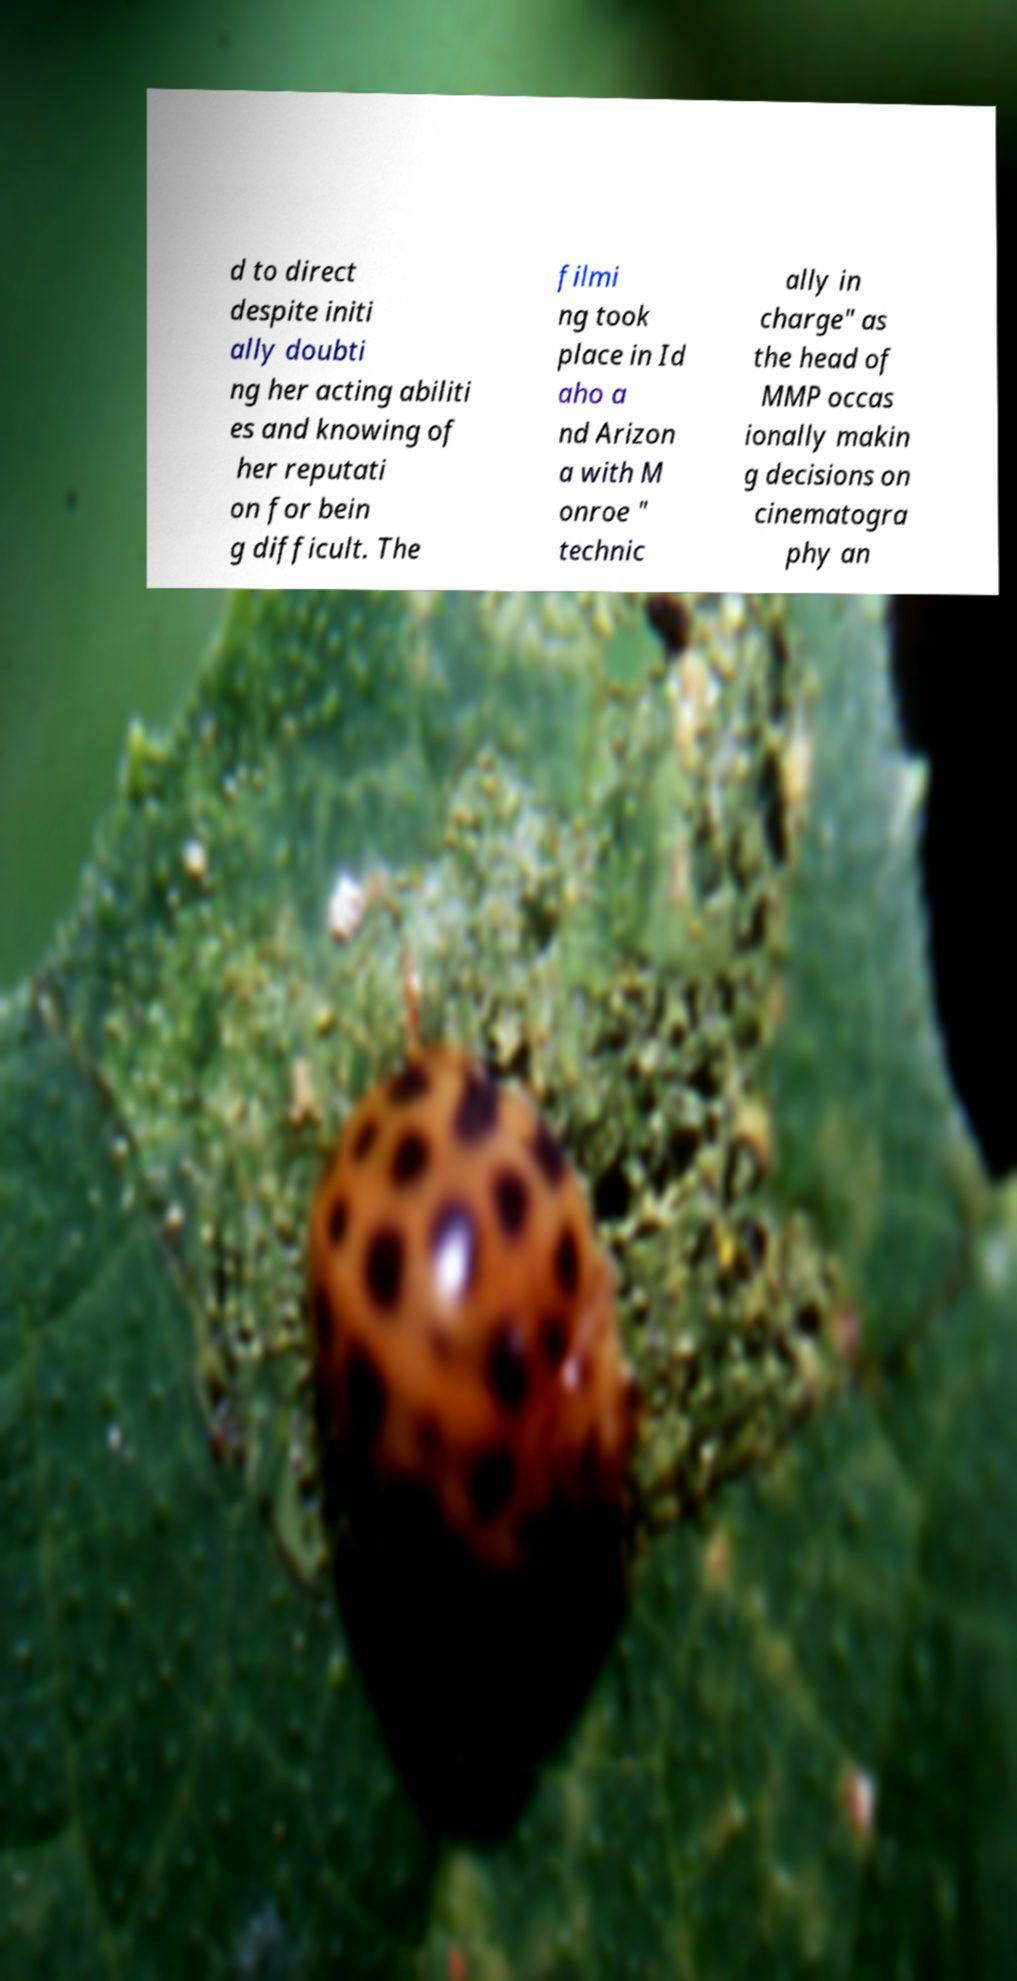I need the written content from this picture converted into text. Can you do that? d to direct despite initi ally doubti ng her acting abiliti es and knowing of her reputati on for bein g difficult. The filmi ng took place in Id aho a nd Arizon a with M onroe " technic ally in charge" as the head of MMP occas ionally makin g decisions on cinematogra phy an 